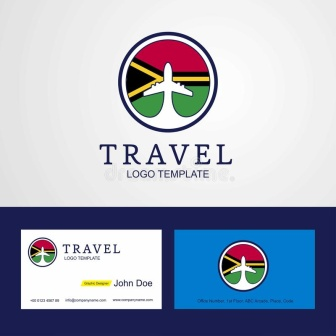What do you think is going on in this snapshot? The image features a meticulously designed logo for a travel agency, complemented by business card layouts embodying a modern, clean aesthetic. The logo, placed against a pristine white backdrop, is enclosed within a vibrant circular border segmented into red, green, blue, and yellow quarters that could symbolize diversity or global reach. Central to the logo is a stylized airplane soaring upwards, its trail painted in a stark yellow, suggesting dynamism and the thrill of travel. Below the logo, 'TRAVEL' is boldly inscribed in an assertive blue, asserting the company's primary business, followed by a subdued 'LOGO TEMPLATE', hinting that this design is readily customizable. Adjacent are two business card examples displaying the logo. One is horizontal with the name 'John Doe' and the other vertical, both maintaining the color scheme and crisp design of the logo. This presentation not only reinforces the company's brand identity but also indicates a targeted approach to potential sophisticated clientele who prize clarity and elegance in business communications. 